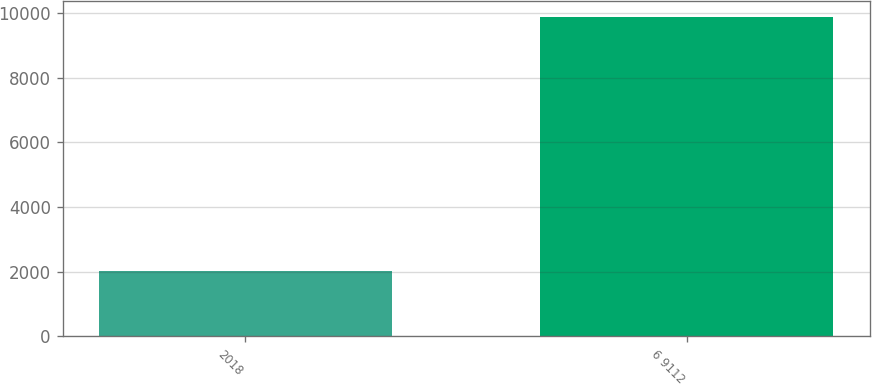Convert chart. <chart><loc_0><loc_0><loc_500><loc_500><bar_chart><fcel>2018<fcel>6 9112<nl><fcel>2017<fcel>9882.3<nl></chart> 